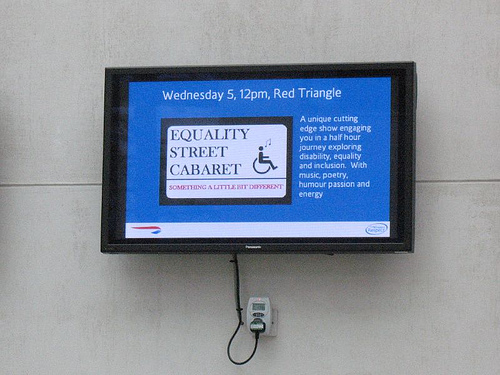<image>
Is the television next to the outlet? No. The television is not positioned next to the outlet. They are located in different areas of the scene. 